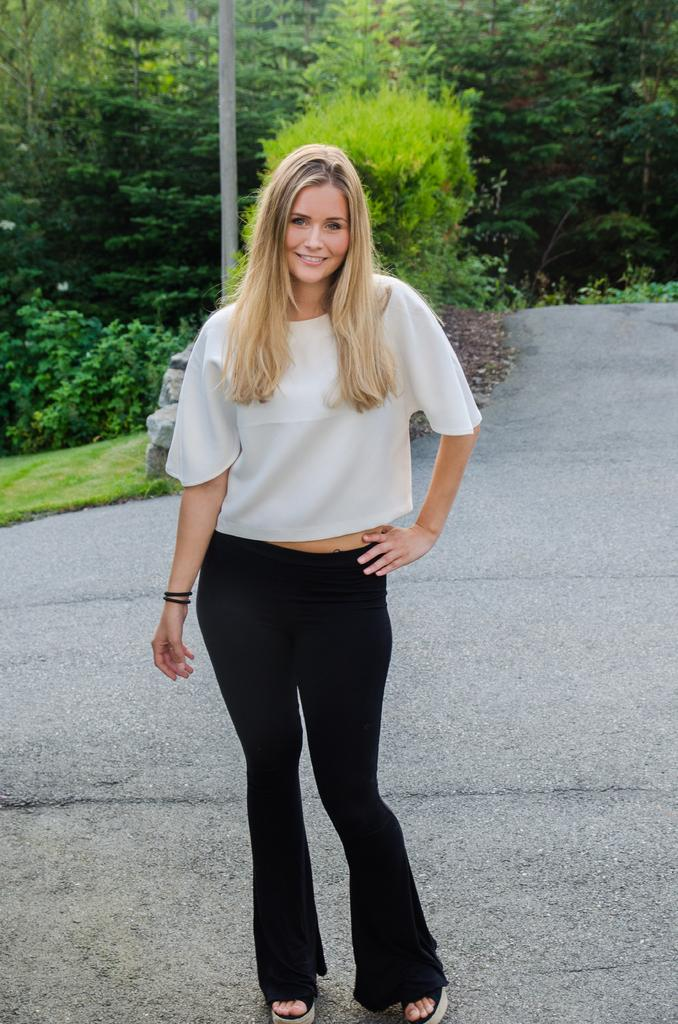Who is the main subject in the image? There is a woman in the image. What is the woman doing in the image? The woman is on the ground and smiling. What can be seen in the background of the image? There is a pole, stones, and trees in the background of the image. What type of action is the woman performing on stage in the image? There is no stage present in the image, and the woman is not performing any action. 